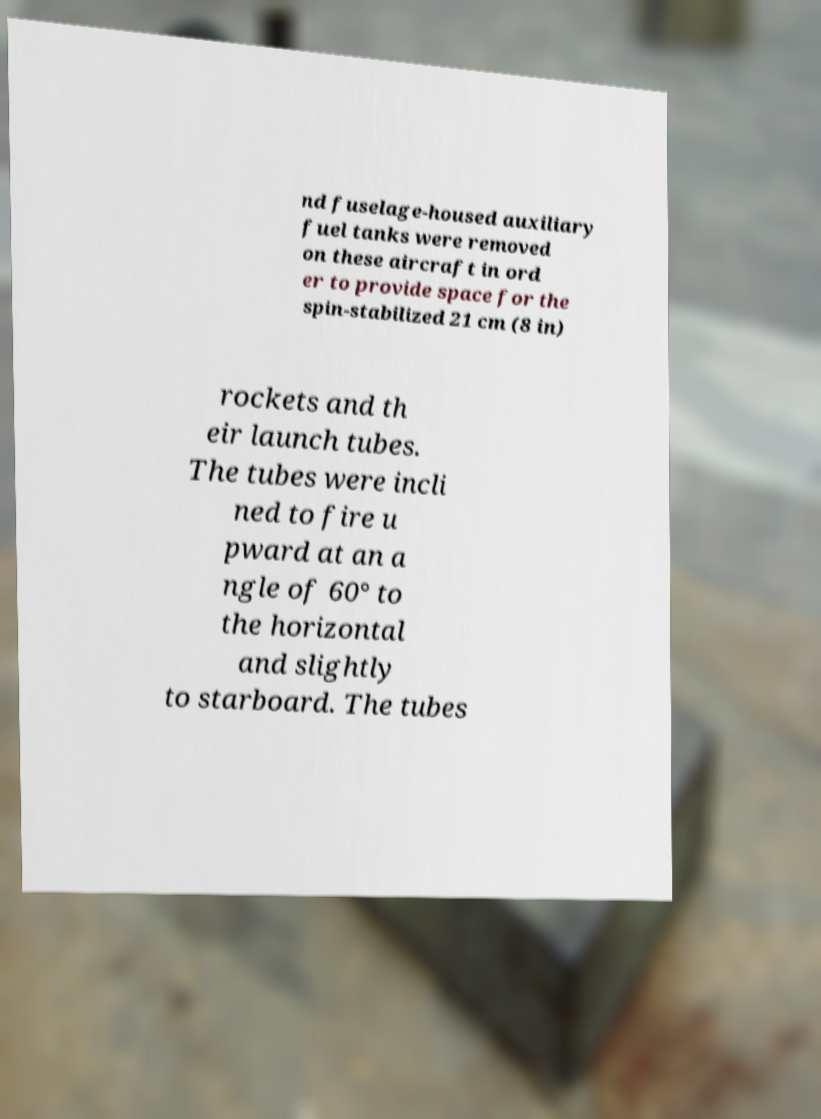Please read and relay the text visible in this image. What does it say? nd fuselage-housed auxiliary fuel tanks were removed on these aircraft in ord er to provide space for the spin-stabilized 21 cm (8 in) rockets and th eir launch tubes. The tubes were incli ned to fire u pward at an a ngle of 60° to the horizontal and slightly to starboard. The tubes 